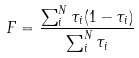Convert formula to latex. <formula><loc_0><loc_0><loc_500><loc_500>F = \frac { \sum _ { i } ^ { N } { \tau _ { i } ( 1 - \tau _ { i } ) } } { \sum _ { i } ^ { N } { \tau _ { i } } }</formula> 